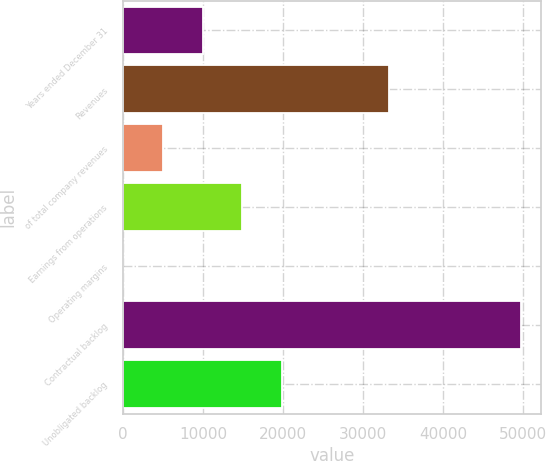Convert chart to OTSL. <chart><loc_0><loc_0><loc_500><loc_500><bar_chart><fcel>Years ended December 31<fcel>Revenues<fcel>of total company revenues<fcel>Earnings from operations<fcel>Operating margins<fcel>Contractual backlog<fcel>Unobligated backlog<nl><fcel>9943.96<fcel>33197<fcel>4976.83<fcel>14911.1<fcel>9.7<fcel>49681<fcel>19878.2<nl></chart> 